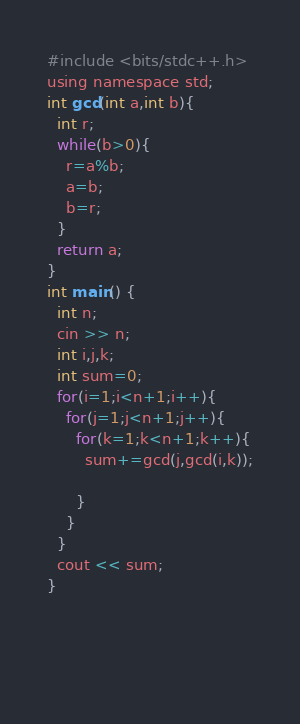Convert code to text. <code><loc_0><loc_0><loc_500><loc_500><_C_>#include <bits/stdc++.h>
using namespace std;
int gcd(int a,int b){
  int r;
  while(b>0){
    r=a%b;
    a=b;
    b=r;
  }
  return a;
} 
int main() {
  int n;
  cin >> n;
  int i,j,k;
  int sum=0;
  for(i=1;i<n+1;i++){
    for(j=1;j<n+1;j++){
      for(k=1;k<n+1;k++){
        sum+=gcd(j,gcd(i,k));
        
      }
    }
  }
  cout << sum;
}
        
  
        
  </code> 